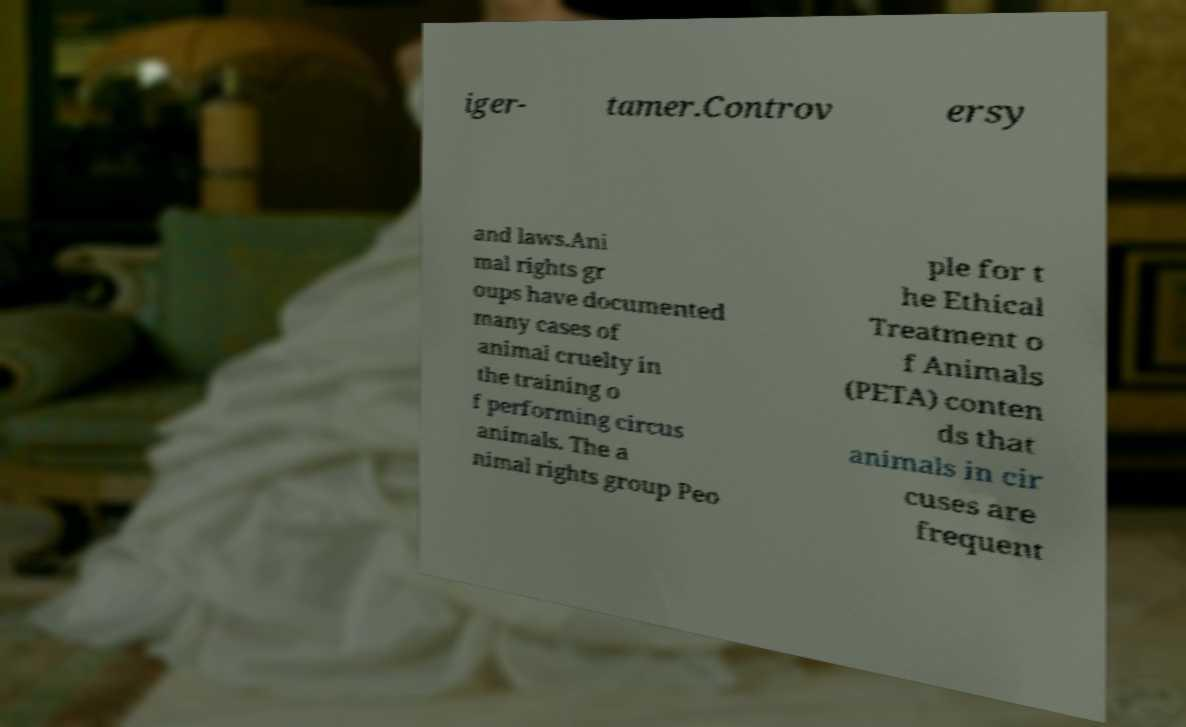Could you assist in decoding the text presented in this image and type it out clearly? iger- tamer.Controv ersy and laws.Ani mal rights gr oups have documented many cases of animal cruelty in the training o f performing circus animals. The a nimal rights group Peo ple for t he Ethical Treatment o f Animals (PETA) conten ds that animals in cir cuses are frequent 